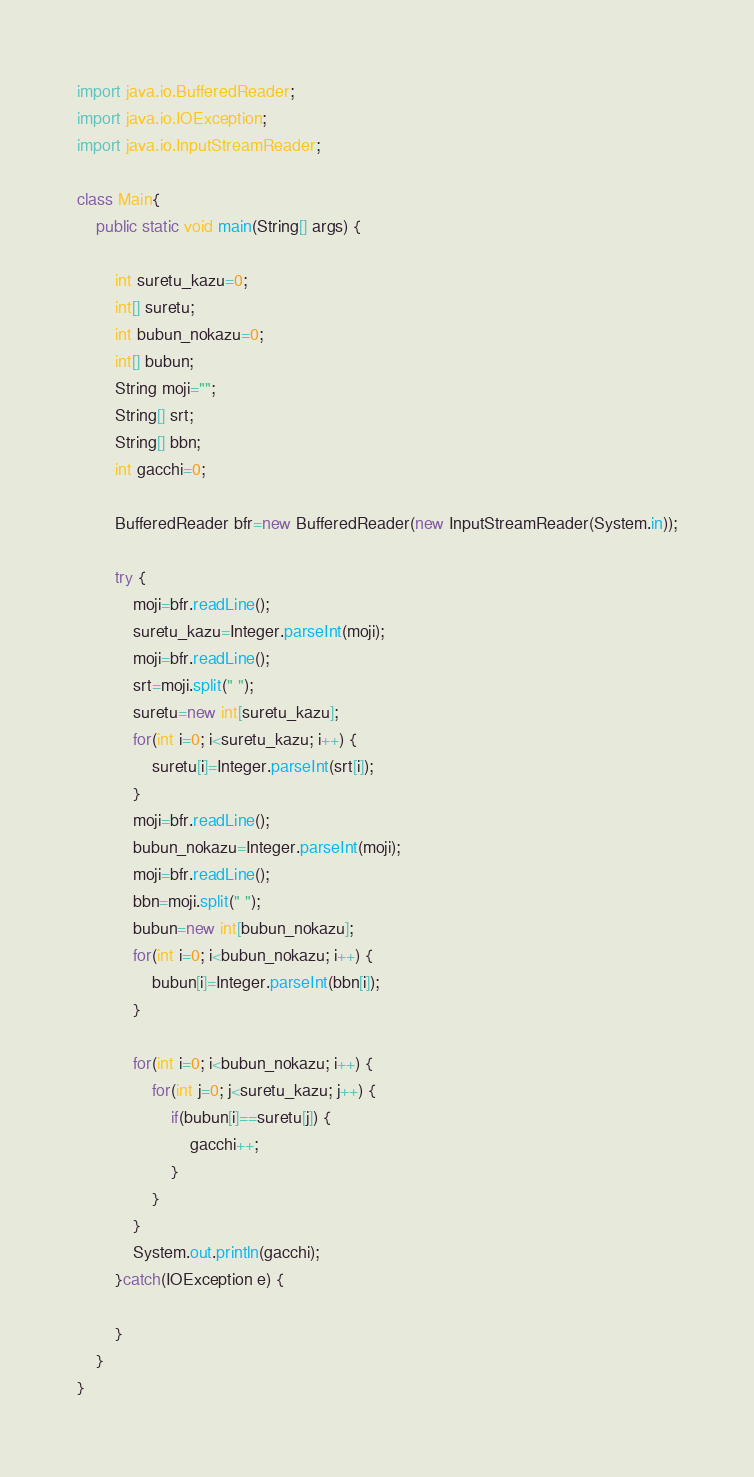Convert code to text. <code><loc_0><loc_0><loc_500><loc_500><_Java_>import java.io.BufferedReader;
import java.io.IOException;
import java.io.InputStreamReader;

class Main{
	public static void main(String[] args) {

		int suretu_kazu=0;
		int[] suretu;
		int bubun_nokazu=0;
		int[] bubun;
		String moji="";
		String[] srt;
		String[] bbn;
		int gacchi=0;

		BufferedReader bfr=new BufferedReader(new InputStreamReader(System.in));

		try {
			moji=bfr.readLine();
			suretu_kazu=Integer.parseInt(moji);
			moji=bfr.readLine();
			srt=moji.split(" ");
			suretu=new int[suretu_kazu];
			for(int i=0; i<suretu_kazu; i++) {
				suretu[i]=Integer.parseInt(srt[i]);
			}
			moji=bfr.readLine();
			bubun_nokazu=Integer.parseInt(moji);
			moji=bfr.readLine();
			bbn=moji.split(" ");
			bubun=new int[bubun_nokazu];
			for(int i=0; i<bubun_nokazu; i++) {
				bubun[i]=Integer.parseInt(bbn[i]);
			}
			
			for(int i=0; i<bubun_nokazu; i++) {
				for(int j=0; j<suretu_kazu; j++) {
					if(bubun[i]==suretu[j]) {
						gacchi++;
					}
				}
			}
			System.out.println(gacchi);
		}catch(IOException e) {

		}
	}
}
</code> 